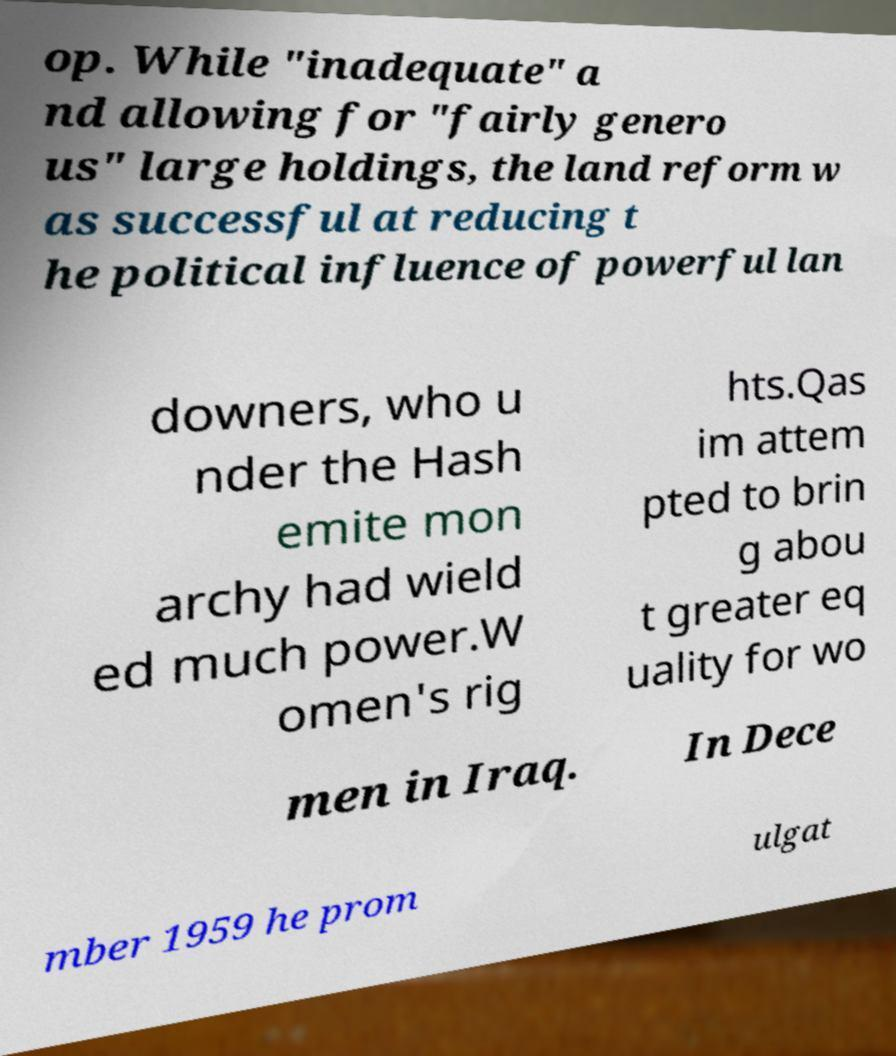Please read and relay the text visible in this image. What does it say? op. While "inadequate" a nd allowing for "fairly genero us" large holdings, the land reform w as successful at reducing t he political influence of powerful lan downers, who u nder the Hash emite mon archy had wield ed much power.W omen's rig hts.Qas im attem pted to brin g abou t greater eq uality for wo men in Iraq. In Dece mber 1959 he prom ulgat 